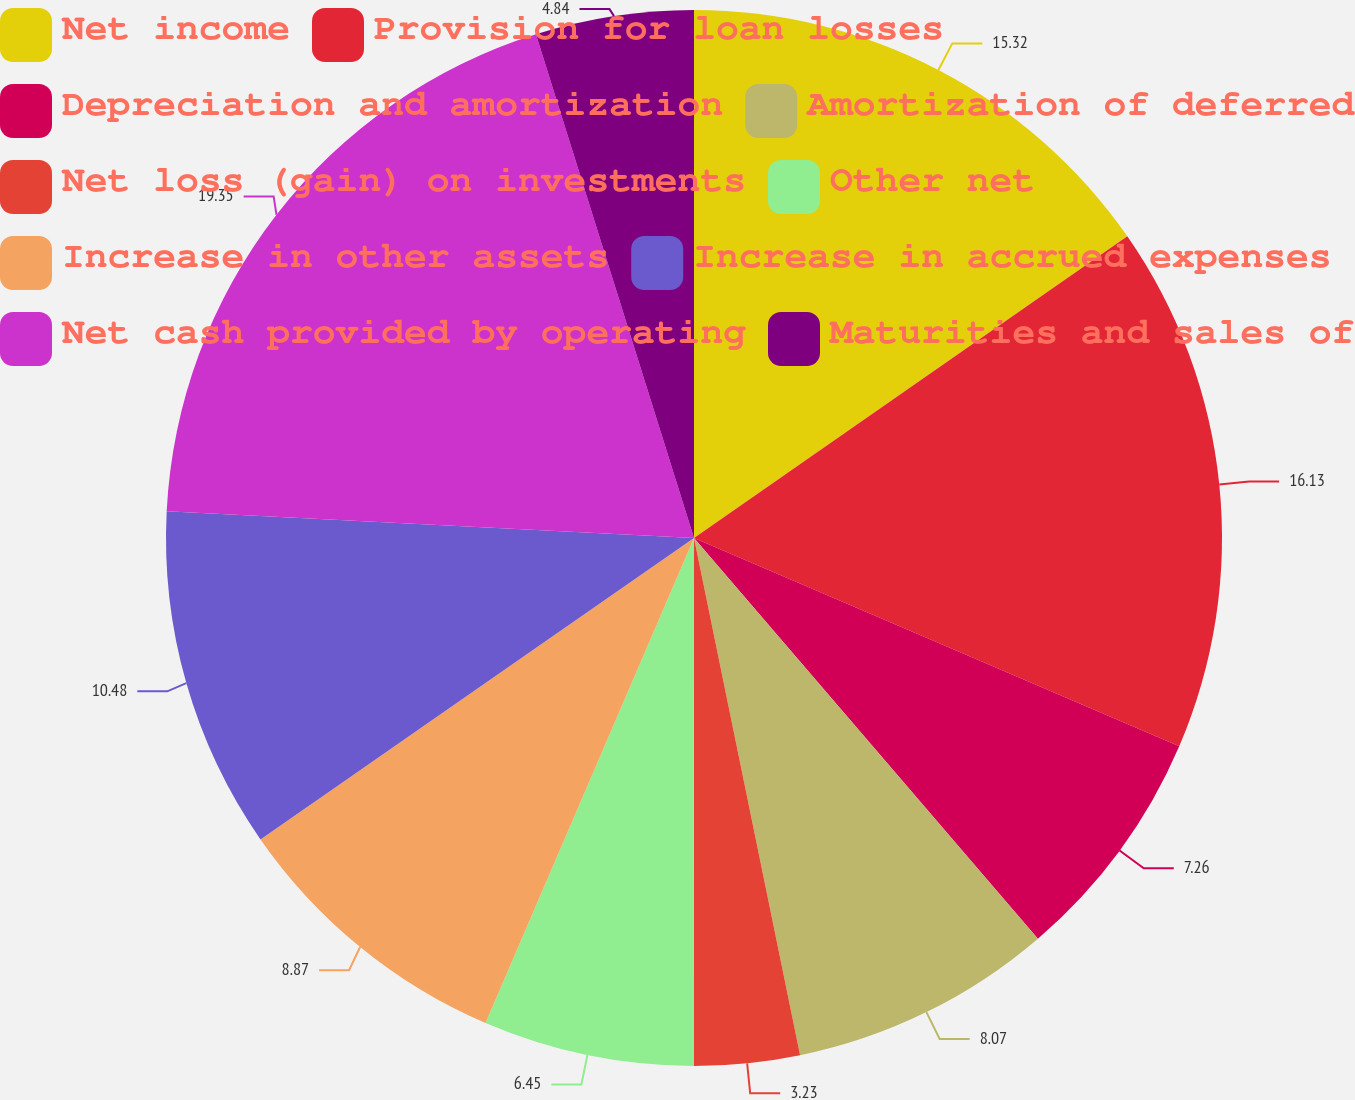Convert chart to OTSL. <chart><loc_0><loc_0><loc_500><loc_500><pie_chart><fcel>Net income<fcel>Provision for loan losses<fcel>Depreciation and amortization<fcel>Amortization of deferred<fcel>Net loss (gain) on investments<fcel>Other net<fcel>Increase in other assets<fcel>Increase in accrued expenses<fcel>Net cash provided by operating<fcel>Maturities and sales of<nl><fcel>15.32%<fcel>16.13%<fcel>7.26%<fcel>8.07%<fcel>3.23%<fcel>6.45%<fcel>8.87%<fcel>10.48%<fcel>19.35%<fcel>4.84%<nl></chart> 